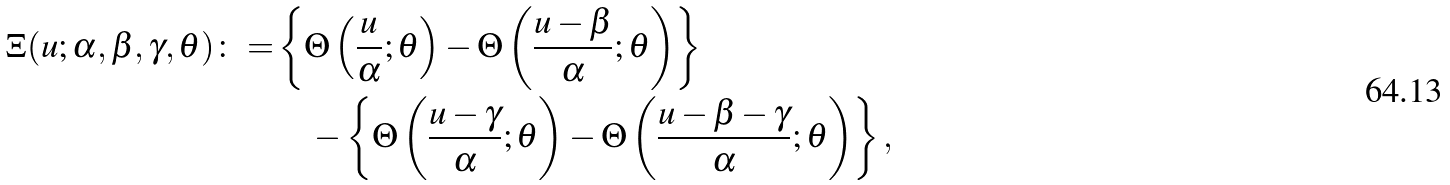Convert formula to latex. <formula><loc_0><loc_0><loc_500><loc_500>\Xi ( u ; \alpha , \beta , \gamma , \theta ) \colon = & \left \{ \Theta \left ( \frac { u } { \alpha } ; \theta \right ) - \Theta \left ( \frac { u - \beta } { \alpha } ; \theta \right ) \right \} \\ & \quad - \left \{ \Theta \left ( \frac { u - \gamma } { \alpha } ; \theta \right ) - \Theta \left ( \frac { u - \beta - \gamma } { \alpha } ; \theta \right ) \right \} ,</formula> 